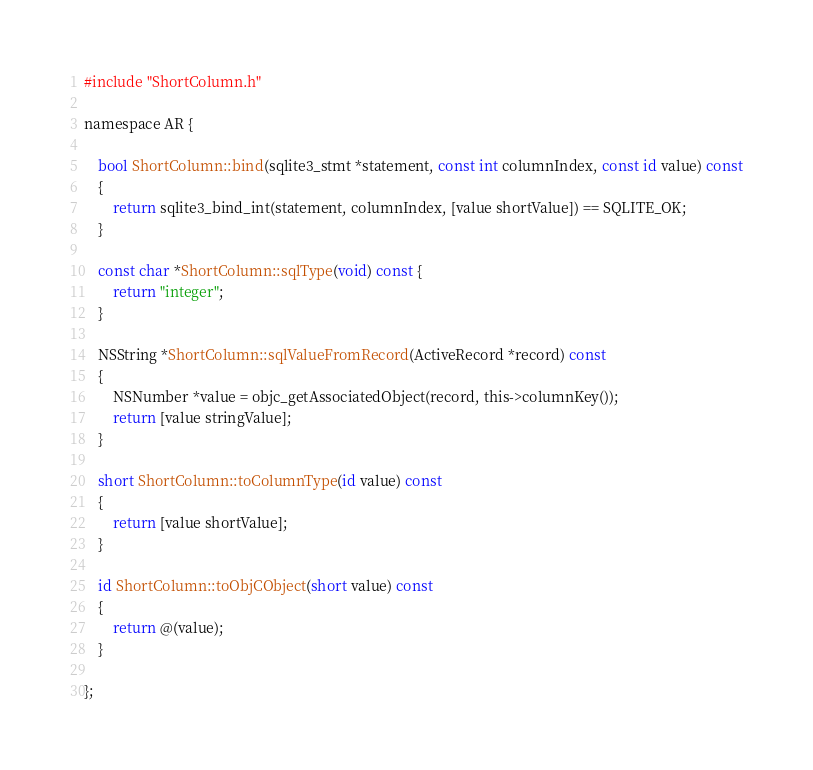<code> <loc_0><loc_0><loc_500><loc_500><_ObjectiveC_>
#include "ShortColumn.h"

namespace AR {

    bool ShortColumn::bind(sqlite3_stmt *statement, const int columnIndex, const id value) const
    {
        return sqlite3_bind_int(statement, columnIndex, [value shortValue]) == SQLITE_OK;
    }

    const char *ShortColumn::sqlType(void) const {
        return "integer";
    }

    NSString *ShortColumn::sqlValueFromRecord(ActiveRecord *record) const
    {
        NSNumber *value = objc_getAssociatedObject(record, this->columnKey());
        return [value stringValue];
    }

    short ShortColumn::toColumnType(id value) const
    {
        return [value shortValue];
    }

    id ShortColumn::toObjCObject(short value) const
    {
        return @(value);
    }

};</code> 